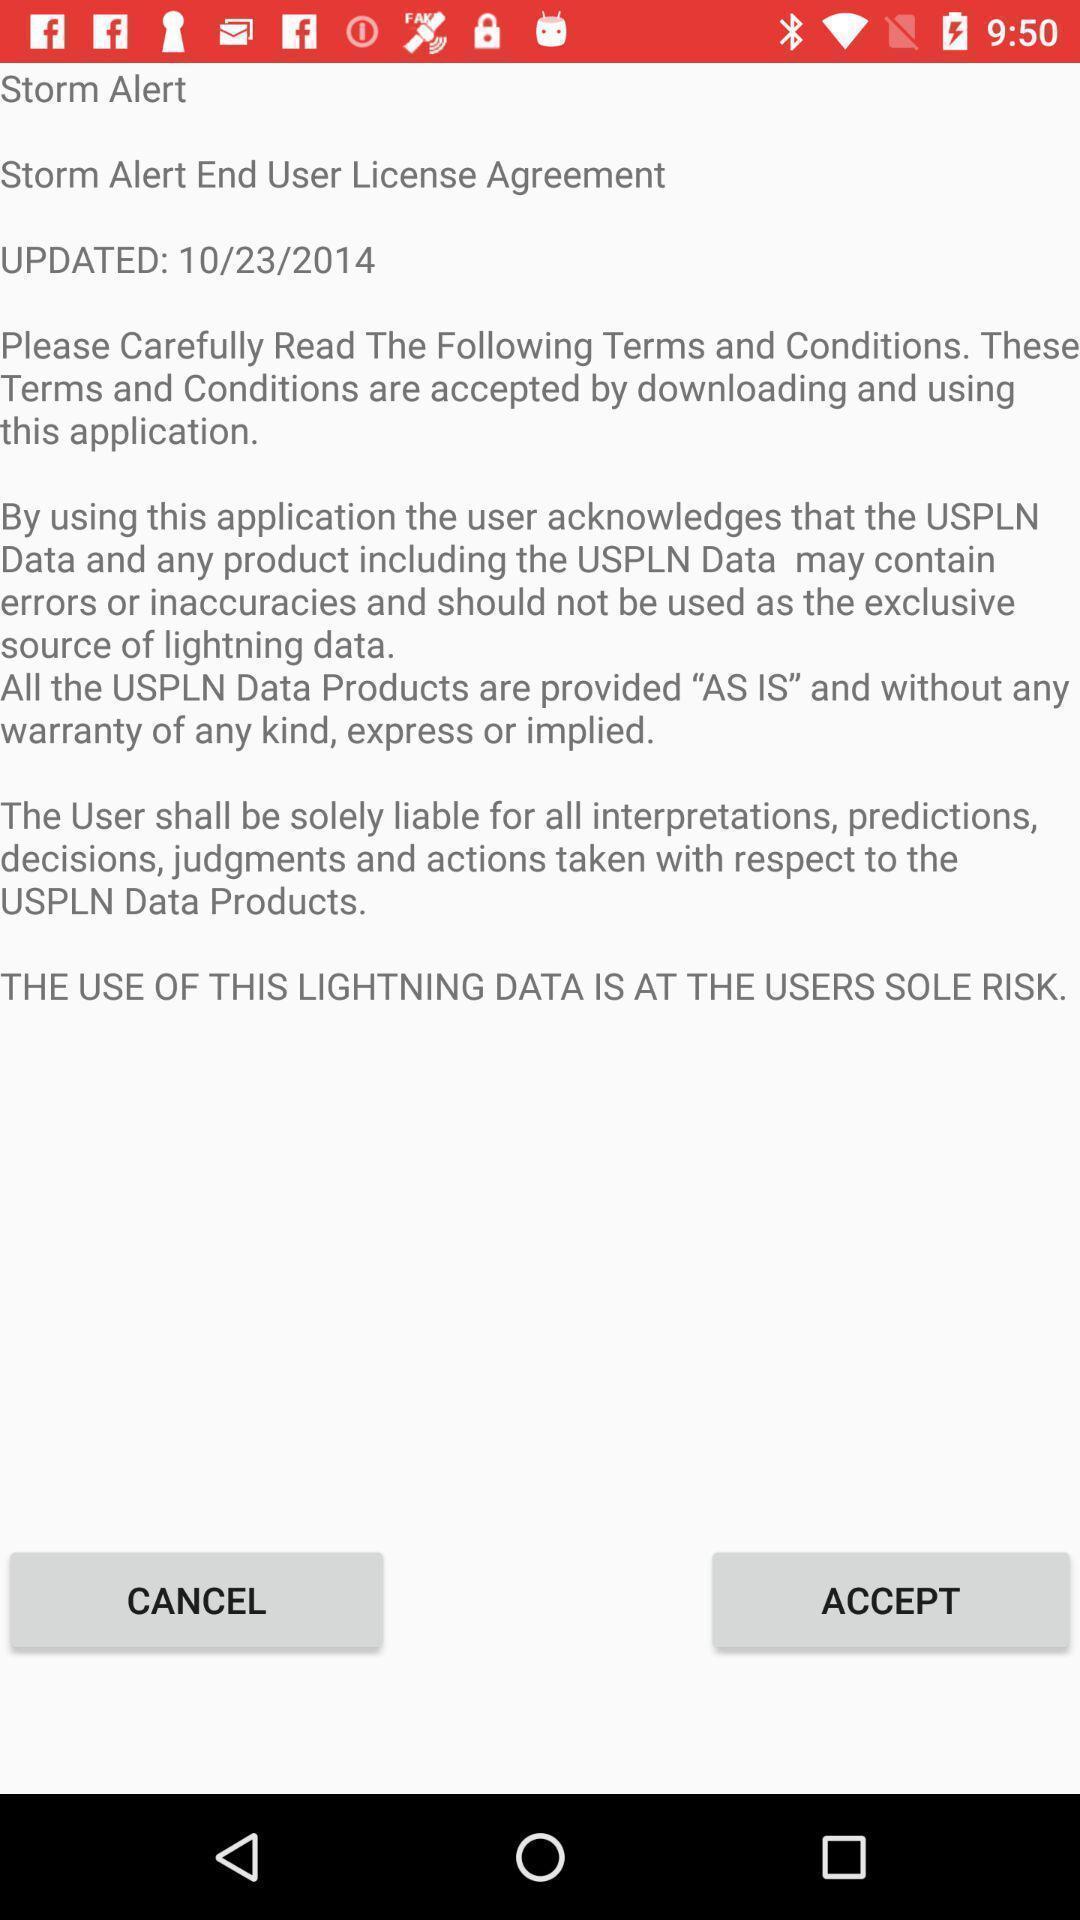Tell me what you see in this picture. Various terms and conditions page displayed. 